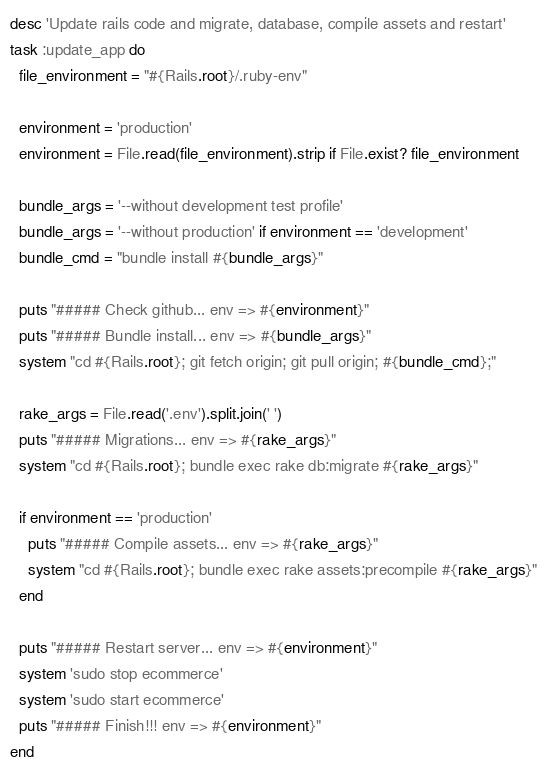<code> <loc_0><loc_0><loc_500><loc_500><_Ruby_>desc 'Update rails code and migrate, database, compile assets and restart'
task :update_app do
  file_environment = "#{Rails.root}/.ruby-env"

  environment = 'production'
  environment = File.read(file_environment).strip if File.exist? file_environment

  bundle_args = '--without development test profile'
  bundle_args = '--without production' if environment == 'development'
  bundle_cmd = "bundle install #{bundle_args}"

  puts "##### Check github... env => #{environment}"
  puts "##### Bundle install... env => #{bundle_args}"
  system "cd #{Rails.root}; git fetch origin; git pull origin; #{bundle_cmd};"

  rake_args = File.read('.env').split.join(' ')
  puts "##### Migrations... env => #{rake_args}"
  system "cd #{Rails.root}; bundle exec rake db:migrate #{rake_args}"

  if environment == 'production'
    puts "##### Compile assets... env => #{rake_args}"
    system "cd #{Rails.root}; bundle exec rake assets:precompile #{rake_args}"
  end

  puts "##### Restart server... env => #{environment}"
  system 'sudo stop ecommerce'
  system 'sudo start ecommerce'
  puts "##### Finish!!! env => #{environment}"
end</code> 